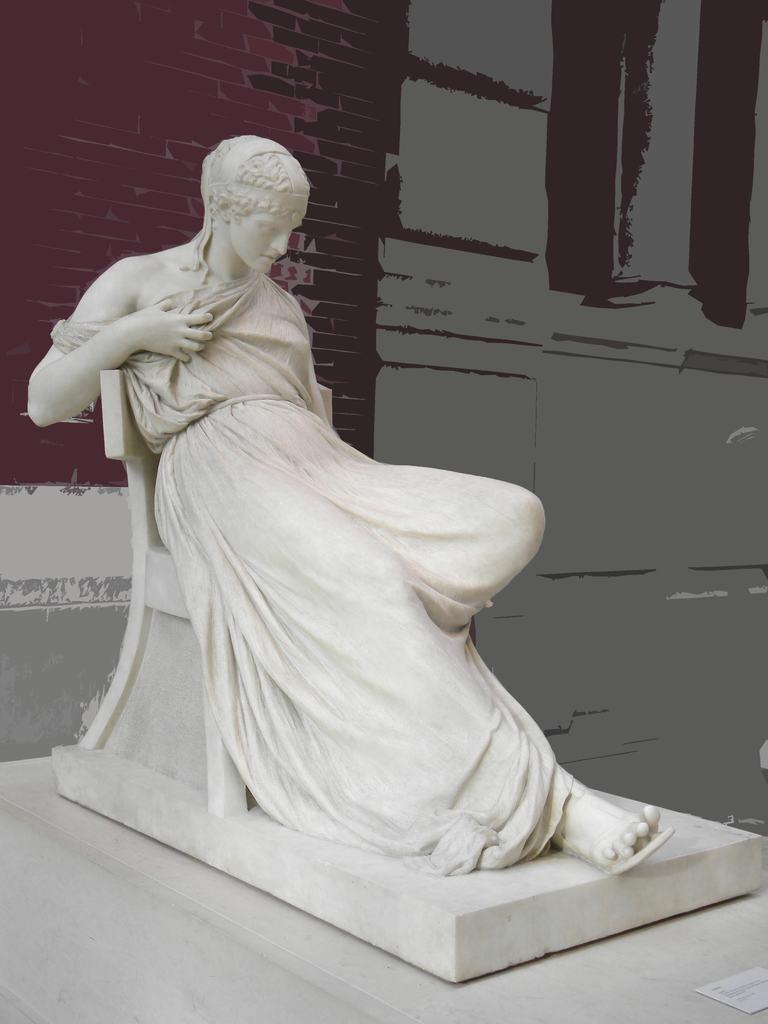What is the main subject in the image? There is a sculpture in the image. What is behind the sculpture? There is a wall behind the sculpture. Is there any text visible in the image? Yes, there is a paper with text in the bottom right corner of the image. What type of animal can be seen interacting with the sculpture in the image? There are no animals present in the image, and the sculpture is not interacting with any other subjects. 